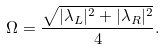Convert formula to latex. <formula><loc_0><loc_0><loc_500><loc_500>\Omega = \frac { \sqrt { | \lambda _ { L } | ^ { 2 } + | \lambda _ { R } | ^ { 2 } } } { 4 } .</formula> 